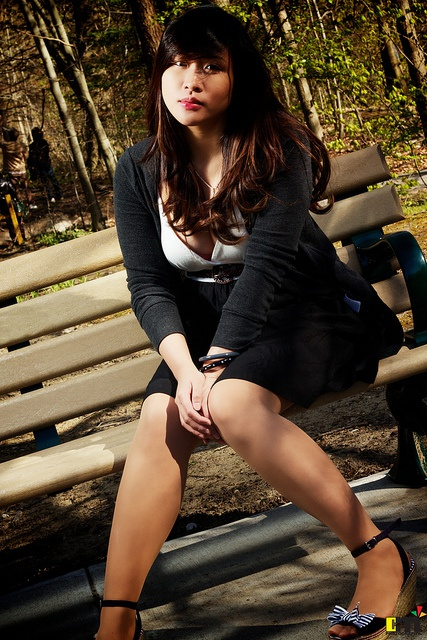Describe the objects in this image and their specific colors. I can see people in black, maroon, salmon, and brown tones, bench in black and tan tones, and people in black, maroon, and olive tones in this image. 